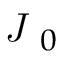<formula> <loc_0><loc_0><loc_500><loc_500>\emph { J } _ { 0 }</formula> 